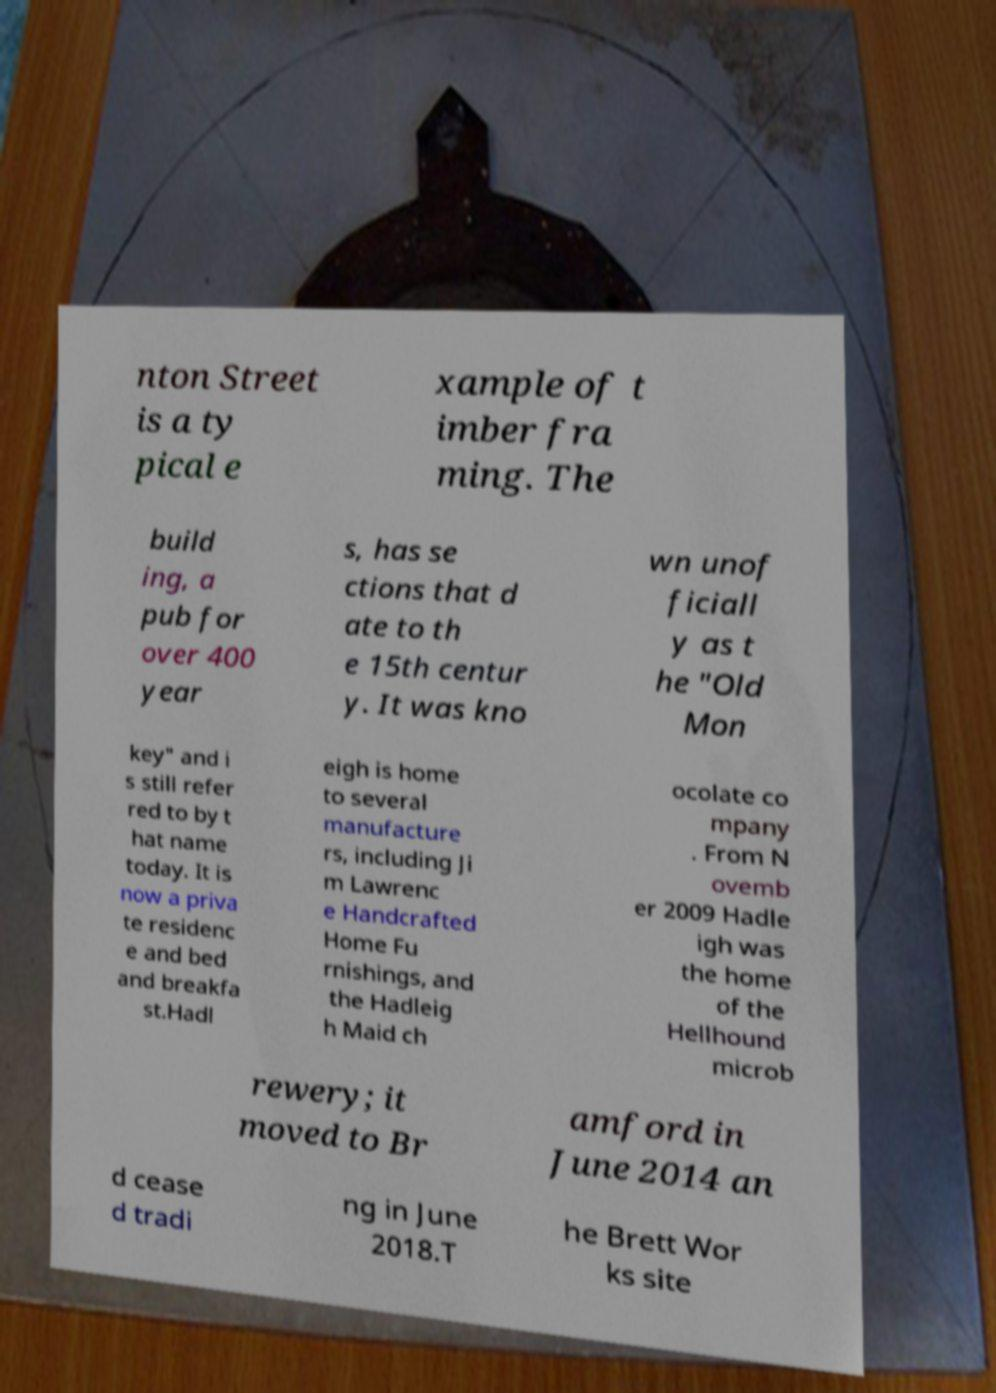Can you read and provide the text displayed in the image?This photo seems to have some interesting text. Can you extract and type it out for me? nton Street is a ty pical e xample of t imber fra ming. The build ing, a pub for over 400 year s, has se ctions that d ate to th e 15th centur y. It was kno wn unof ficiall y as t he "Old Mon key" and i s still refer red to by t hat name today. It is now a priva te residenc e and bed and breakfa st.Hadl eigh is home to several manufacture rs, including Ji m Lawrenc e Handcrafted Home Fu rnishings, and the Hadleig h Maid ch ocolate co mpany . From N ovemb er 2009 Hadle igh was the home of the Hellhound microb rewery; it moved to Br amford in June 2014 an d cease d tradi ng in June 2018.T he Brett Wor ks site 